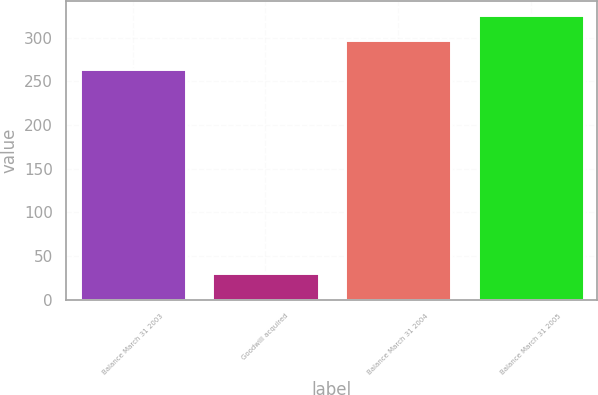Convert chart to OTSL. <chart><loc_0><loc_0><loc_500><loc_500><bar_chart><fcel>Balance March 31 2003<fcel>Goodwill acquired<fcel>Balance March 31 2004<fcel>Balance March 31 2005<nl><fcel>264.6<fcel>30<fcel>297.7<fcel>326<nl></chart> 